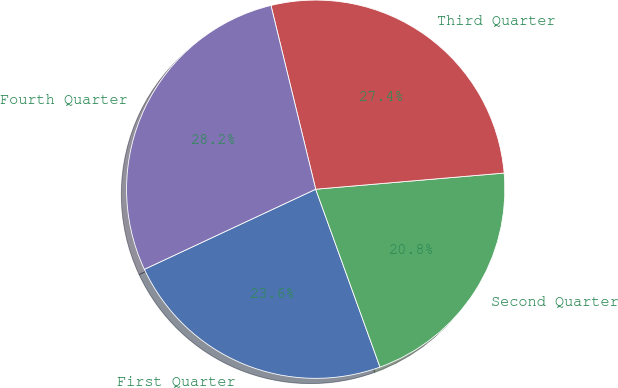<chart> <loc_0><loc_0><loc_500><loc_500><pie_chart><fcel>First Quarter<fcel>Second Quarter<fcel>Third Quarter<fcel>Fourth Quarter<nl><fcel>23.56%<fcel>20.84%<fcel>27.44%<fcel>28.16%<nl></chart> 